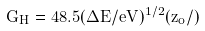<formula> <loc_0><loc_0><loc_500><loc_500>G _ { H } = 4 8 . 5 ( \Delta E / e V ) ^ { 1 / 2 } ( z _ { o } / \AA )</formula> 